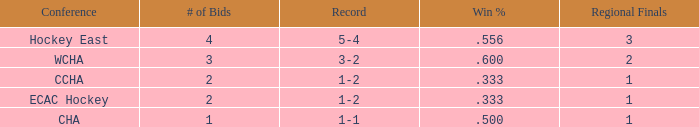What is the average Regional Finals score when the record is 3-2 and there are more than 3 bids? None. Write the full table. {'header': ['Conference', '# of Bids', 'Record', 'Win %', 'Regional Finals'], 'rows': [['Hockey East', '4', '5-4', '.556', '3'], ['WCHA', '3', '3-2', '.600', '2'], ['CCHA', '2', '1-2', '.333', '1'], ['ECAC Hockey', '2', '1-2', '.333', '1'], ['CHA', '1', '1-1', '.500', '1']]} 